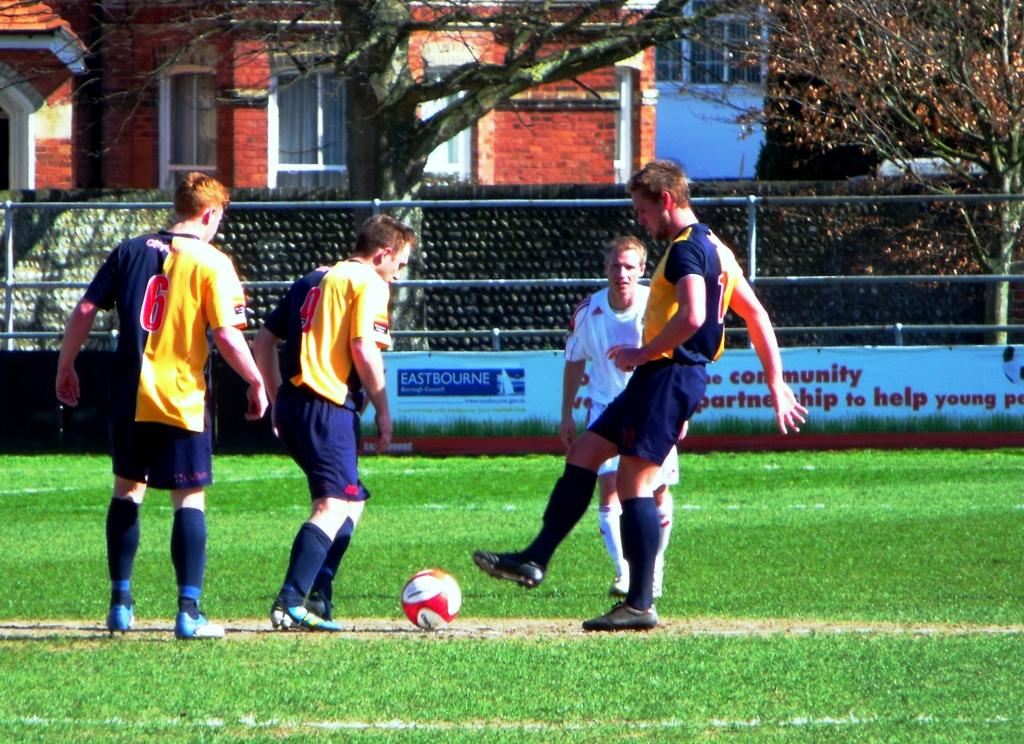Provide a one-sentence caption for the provided image. A few soccer players in front of a sponsorship sign reading Eastbourne. 